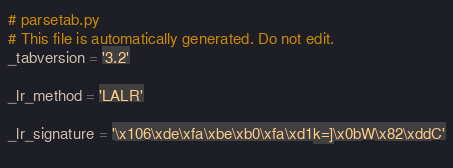<code> <loc_0><loc_0><loc_500><loc_500><_Python_>
# parsetab.py
# This file is automatically generated. Do not edit.
_tabversion = '3.2'

_lr_method = 'LALR'

_lr_signature = '\x106\xde\xfa\xbe\xb0\xfa\xd1k=]\x0bW\x82\xddC'
    </code> 